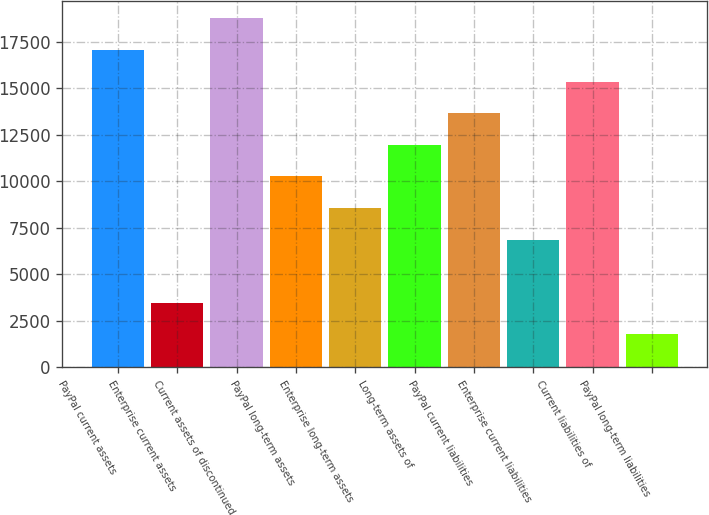Convert chart to OTSL. <chart><loc_0><loc_0><loc_500><loc_500><bar_chart><fcel>PayPal current assets<fcel>Enterprise current assets<fcel>Current assets of discontinued<fcel>PayPal long-term assets<fcel>Enterprise long-term assets<fcel>Long-term assets of<fcel>PayPal current liabilities<fcel>Enterprise current liabilities<fcel>Current liabilities of<fcel>PayPal long-term liabilities<nl><fcel>17048<fcel>3468.8<fcel>18745.4<fcel>10258.4<fcel>8561<fcel>11955.8<fcel>13653.2<fcel>6863.6<fcel>15350.6<fcel>1771.4<nl></chart> 